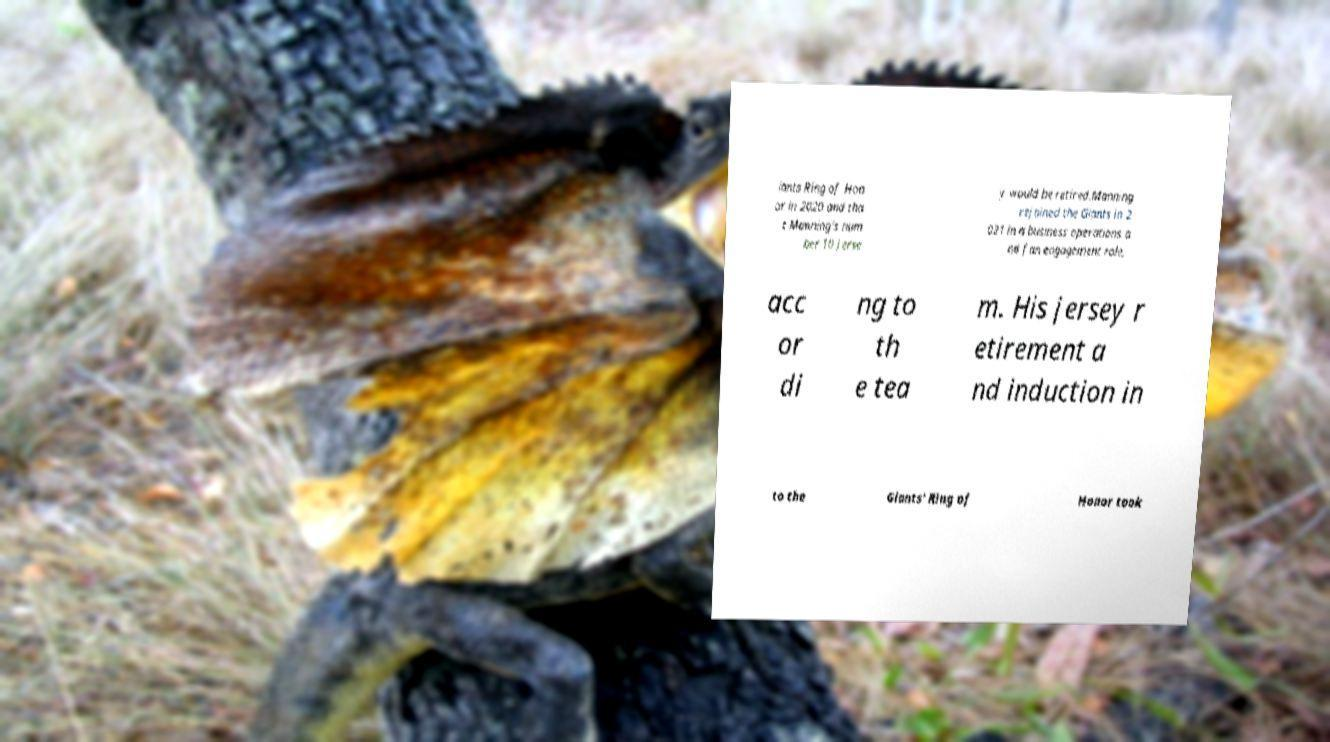Could you assist in decoding the text presented in this image and type it out clearly? iants Ring of Hon or in 2020 and tha t Manning's num ber 10 jerse y would be retired.Manning rejoined the Giants in 2 021 in a business operations a nd fan engagement role, acc or di ng to th e tea m. His jersey r etirement a nd induction in to the Giants' Ring of Honor took 